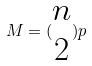<formula> <loc_0><loc_0><loc_500><loc_500>M = ( \begin{matrix} n \\ 2 \end{matrix} ) p</formula> 